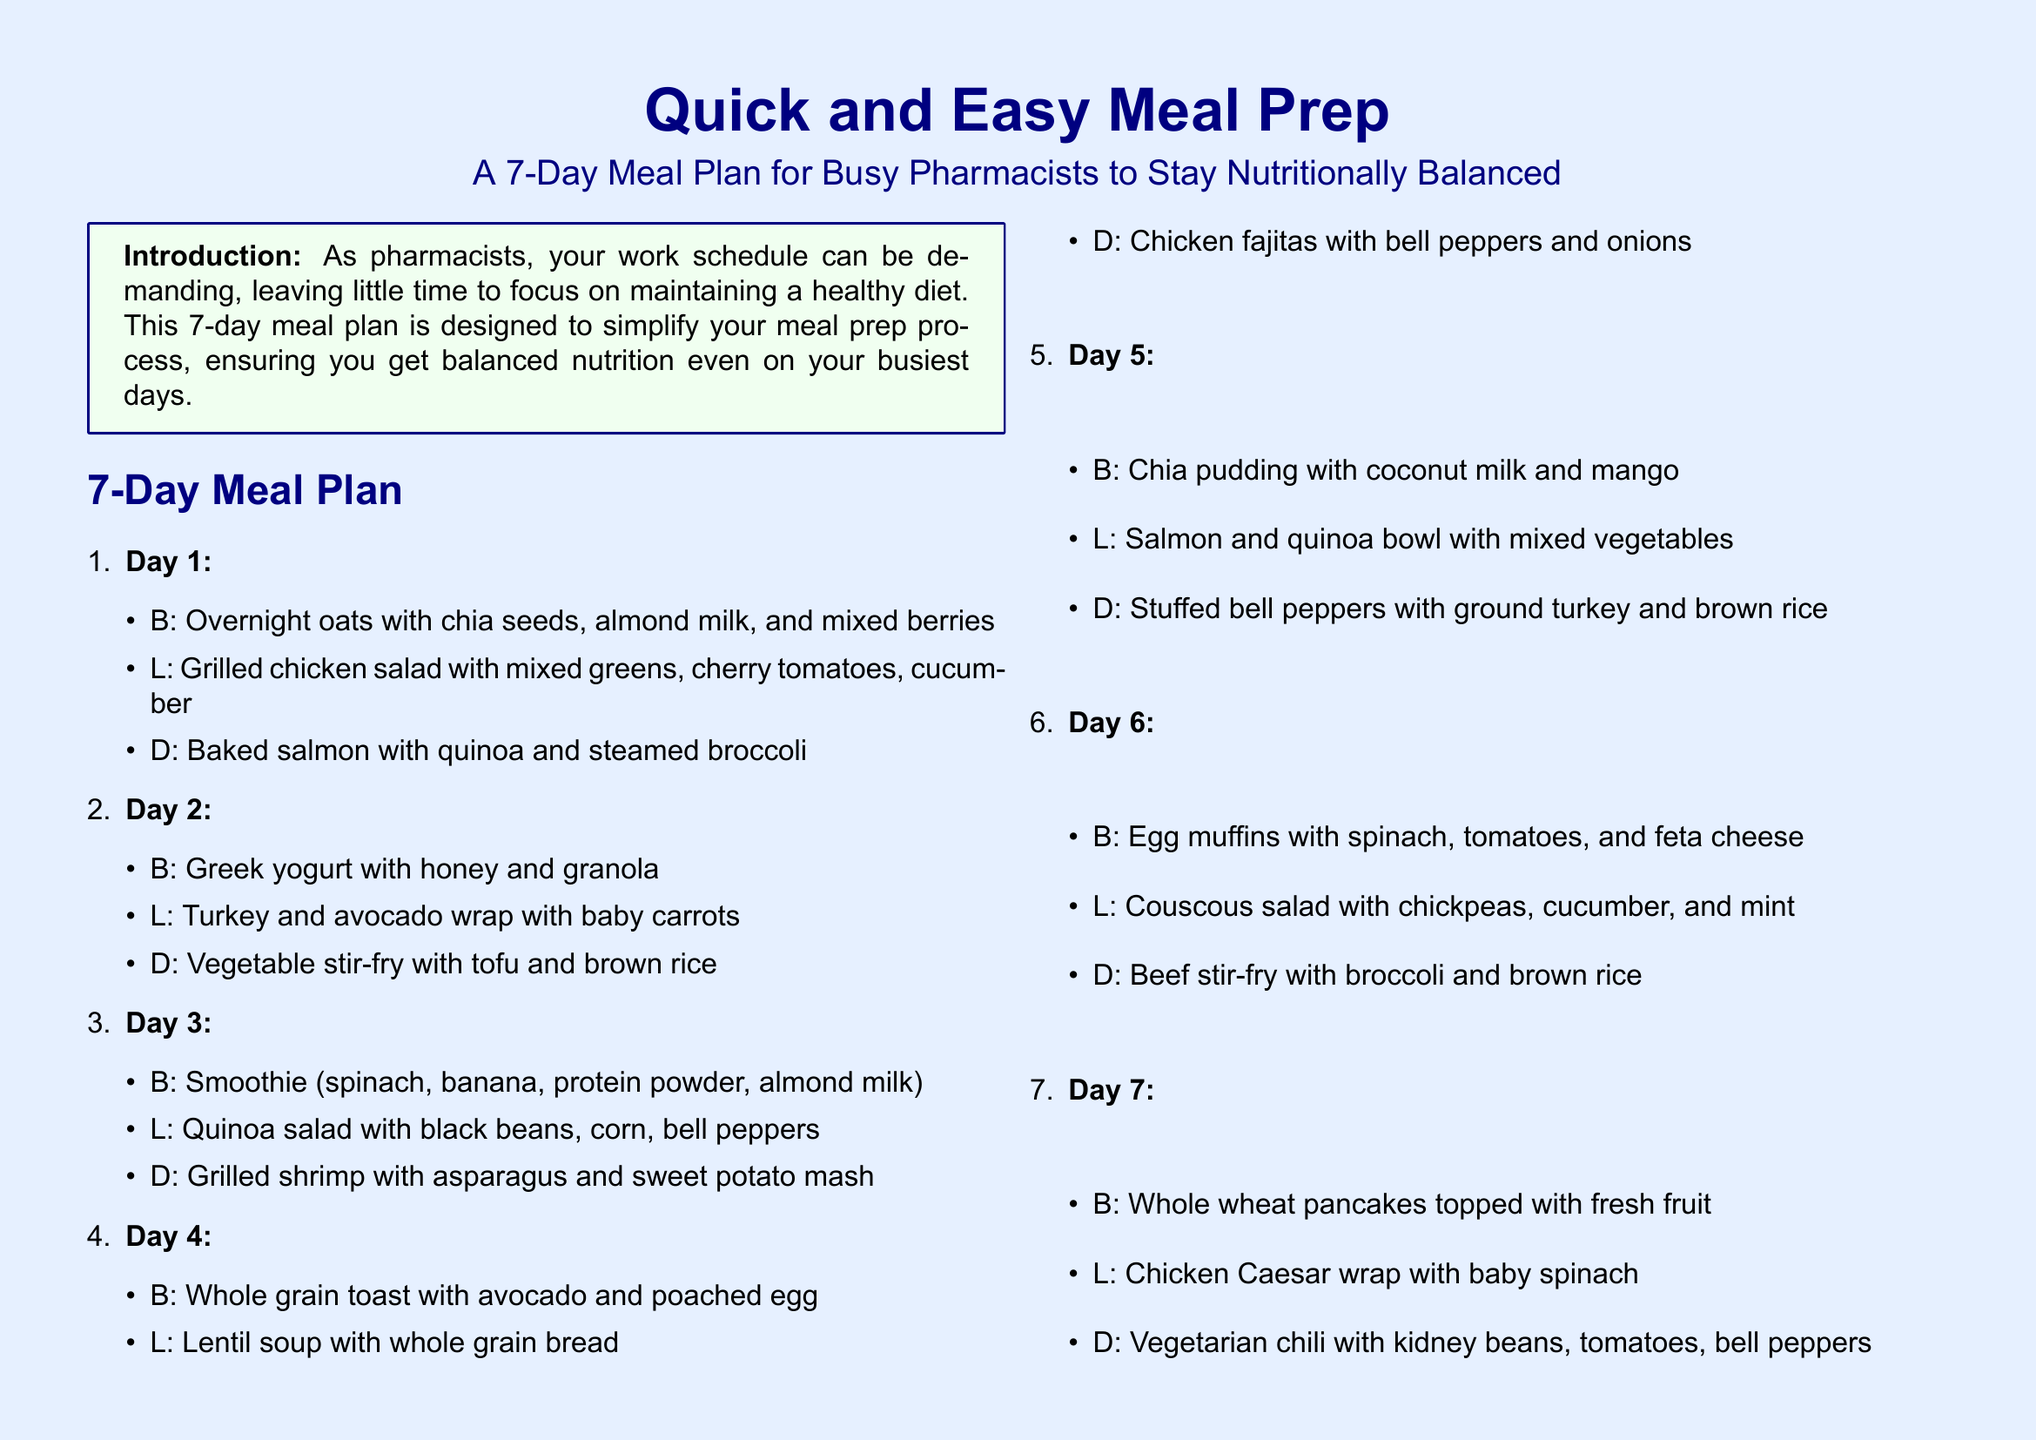What is the title of the meal plan? The title of the meal plan is found at the top of the document, stating what the document is about.
Answer: Quick and Easy Meal Prep: A 7-Day Meal Plan for Busy Pharmacists to Stay Nutritionally Balanced How many meals are suggested for each day? The document specifies breakfast, lunch, and dinner for each day, which accounts for three meals.
Answer: Three meals What is one suggested snack? The document lists multiple snack ideas under a specific section, allowing for retrieval of one example.
Answer: Apple slices with peanut butter What is the primary focus of the meal plan? The introduction discusses the intended purpose of the meal plan, highlighting its benefits for the target audience.
Answer: Simplify meal prep process What is the recommended number of servings of fruits and vegetables daily? The nutritional tips section specifies a daily recommendation regarding fruit and vegetable consumption.
Answer: At least 5 servings Which day includes vegetable stir-fry? The meal plan lists meals for each day, allowing identification of which day features a specific meal.
Answer: Day 2 What type of protein is suggested for Day 3's lunch? The meal plan clarifies the components of each meal, including specific proteins in various dishes.
Answer: Black beans How many hours should be dedicated to meal prep on the weekend? The preparation tips section suggests a specific duration for meal prep.
Answer: A couple of hours What is a healthy fat option listed in the nutritional tips? The nutritional tips section provides examples of healthy fats, allowing for easy retrieval of options.
Answer: Avocados 